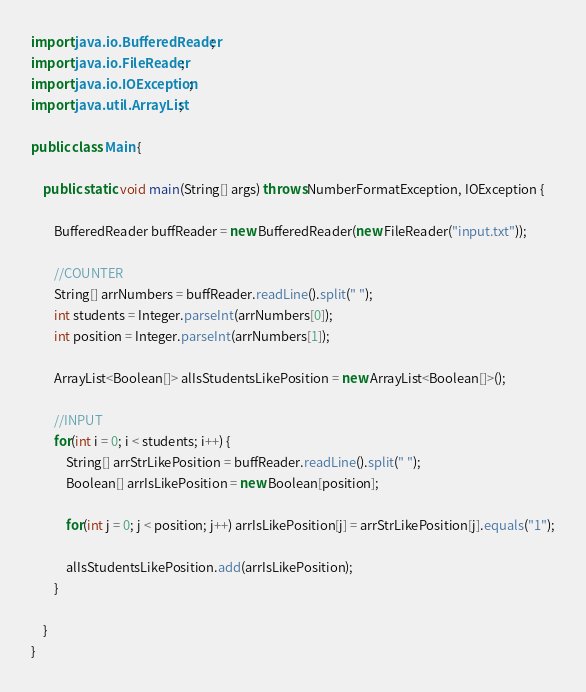Convert code to text. <code><loc_0><loc_0><loc_500><loc_500><_Java_>import java.io.BufferedReader;
import java.io.FileReader;
import java.io.IOException;
import java.util.ArrayList;

public class Main {

	public static void main(String[] args) throws NumberFormatException, IOException {

		BufferedReader buffReader = new BufferedReader(new FileReader("input.txt"));

		//COUNTER
		String[] arrNumbers = buffReader.readLine().split(" ");
		int students = Integer.parseInt(arrNumbers[0]);
		int position = Integer.parseInt(arrNumbers[1]);

		ArrayList<Boolean[]> alIsStudentsLikePosition = new ArrayList<Boolean[]>();

		//INPUT
		for(int i = 0; i < students; i++) {
			String[] arrStrLikePosition = buffReader.readLine().split(" ");
			Boolean[] arrIsLikePosition = new Boolean[position];

			for(int j = 0; j < position; j++) arrIsLikePosition[j] = arrStrLikePosition[j].equals("1");

			alIsStudentsLikePosition.add(arrIsLikePosition);
		}

	}
}</code> 